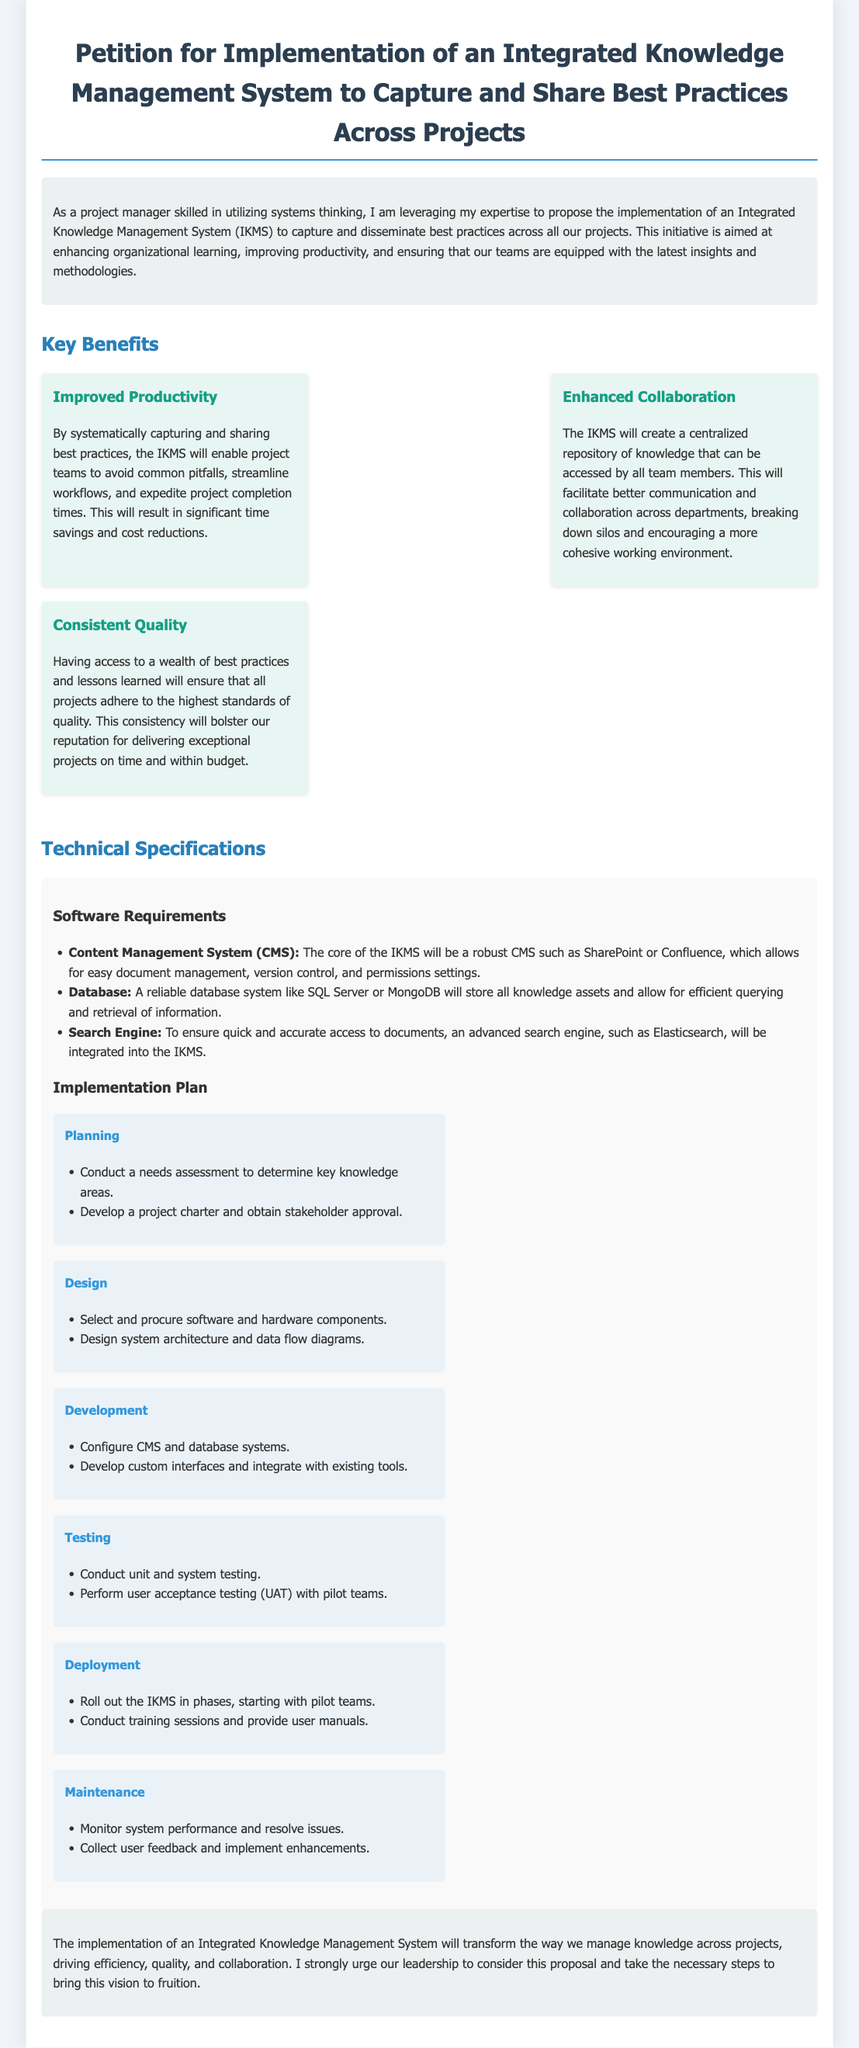What is the title of the petition? The title of the petition states the purpose of the document, which is to propose an Integrated Knowledge Management System.
Answer: Petition for Implementation of an Integrated Knowledge Management System to Capture and Share Best Practices Across Projects What is one key benefit of the IKMS? The document lists several benefits of the IKMS; one of them focuses on productivity improvements.
Answer: Improved Productivity What is a required software component for the IKMS? The document specifies a Content Management System as a core software requirement for the IKMS.
Answer: Content Management System Which phase comes after the Design phase? According to the Implementation Plan in the document, the phase that follows Design is clearly listed as Development.
Answer: Development How many phases are outlined in the Implementation Plan? The document details a structured Implementation Plan, which includes a specific number of phases listed.
Answer: Six phases What type of testing is performed with pilot teams? The document mentions user acceptance testing, which is specifically conducted with pilot teams during the testing phase.
Answer: User Acceptance Testing What does the acronym UAT stand for? The document refers to user acceptance testing with its acronym, which is commonly recognized as UAT.
Answer: UAT What is the main goal of proposing the IKMS? The primary goal of the petition is stated in the introduction: to enhance organizational learning and productivity.
Answer: Enhance organizational learning and productivity What does the document call the proposed system? Throughout the document, the proposed system is consistently referred to as the Integrated Knowledge Management System.
Answer: Integrated Knowledge Management System 